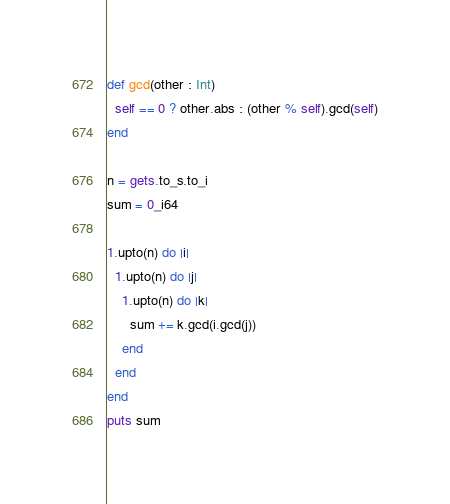<code> <loc_0><loc_0><loc_500><loc_500><_Ruby_>def gcd(other : Int)
  self == 0 ? other.abs : (other % self).gcd(self)
end

n = gets.to_s.to_i
sum = 0_i64

1.upto(n) do |i|
  1.upto(n) do |j|
    1.upto(n) do |k|
      sum += k.gcd(i.gcd(j))
    end
  end
end
puts sum</code> 